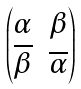Convert formula to latex. <formula><loc_0><loc_0><loc_500><loc_500>\begin{pmatrix} \alpha & \beta \\ \overline { \beta } & \overline { \alpha } \end{pmatrix}</formula> 